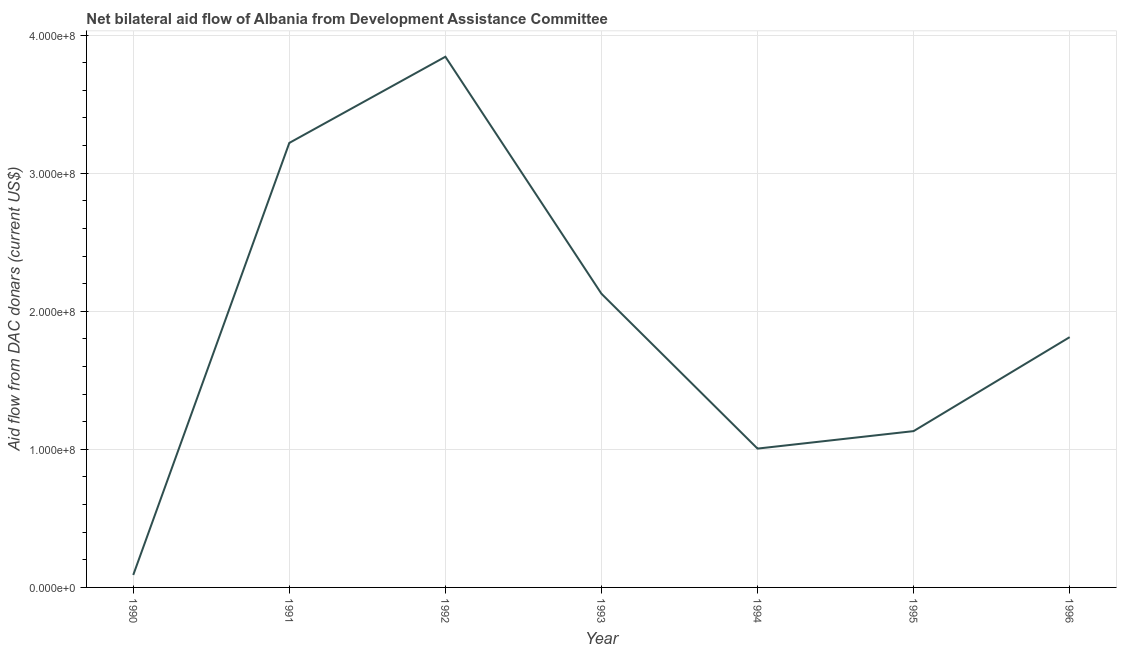What is the net bilateral aid flows from dac donors in 1990?
Ensure brevity in your answer.  9.02e+06. Across all years, what is the maximum net bilateral aid flows from dac donors?
Your response must be concise. 3.84e+08. Across all years, what is the minimum net bilateral aid flows from dac donors?
Make the answer very short. 9.02e+06. What is the sum of the net bilateral aid flows from dac donors?
Provide a short and direct response. 1.32e+09. What is the difference between the net bilateral aid flows from dac donors in 1990 and 1994?
Your answer should be very brief. -9.15e+07. What is the average net bilateral aid flows from dac donors per year?
Your answer should be compact. 1.89e+08. What is the median net bilateral aid flows from dac donors?
Keep it short and to the point. 1.81e+08. In how many years, is the net bilateral aid flows from dac donors greater than 260000000 US$?
Give a very brief answer. 2. What is the ratio of the net bilateral aid flows from dac donors in 1992 to that in 1995?
Provide a short and direct response. 3.4. Is the net bilateral aid flows from dac donors in 1991 less than that in 1993?
Give a very brief answer. No. What is the difference between the highest and the second highest net bilateral aid flows from dac donors?
Provide a succinct answer. 6.24e+07. What is the difference between the highest and the lowest net bilateral aid flows from dac donors?
Your answer should be compact. 3.75e+08. Does the graph contain any zero values?
Your answer should be compact. No. What is the title of the graph?
Provide a short and direct response. Net bilateral aid flow of Albania from Development Assistance Committee. What is the label or title of the Y-axis?
Your answer should be compact. Aid flow from DAC donars (current US$). What is the Aid flow from DAC donars (current US$) in 1990?
Give a very brief answer. 9.02e+06. What is the Aid flow from DAC donars (current US$) in 1991?
Ensure brevity in your answer.  3.22e+08. What is the Aid flow from DAC donars (current US$) of 1992?
Provide a short and direct response. 3.84e+08. What is the Aid flow from DAC donars (current US$) in 1993?
Offer a very short reply. 2.13e+08. What is the Aid flow from DAC donars (current US$) of 1994?
Your response must be concise. 1.01e+08. What is the Aid flow from DAC donars (current US$) of 1995?
Keep it short and to the point. 1.13e+08. What is the Aid flow from DAC donars (current US$) in 1996?
Ensure brevity in your answer.  1.81e+08. What is the difference between the Aid flow from DAC donars (current US$) in 1990 and 1991?
Provide a succinct answer. -3.13e+08. What is the difference between the Aid flow from DAC donars (current US$) in 1990 and 1992?
Your answer should be compact. -3.75e+08. What is the difference between the Aid flow from DAC donars (current US$) in 1990 and 1993?
Provide a succinct answer. -2.04e+08. What is the difference between the Aid flow from DAC donars (current US$) in 1990 and 1994?
Your answer should be compact. -9.15e+07. What is the difference between the Aid flow from DAC donars (current US$) in 1990 and 1995?
Your response must be concise. -1.04e+08. What is the difference between the Aid flow from DAC donars (current US$) in 1990 and 1996?
Provide a short and direct response. -1.72e+08. What is the difference between the Aid flow from DAC donars (current US$) in 1991 and 1992?
Make the answer very short. -6.24e+07. What is the difference between the Aid flow from DAC donars (current US$) in 1991 and 1993?
Give a very brief answer. 1.09e+08. What is the difference between the Aid flow from DAC donars (current US$) in 1991 and 1994?
Your response must be concise. 2.21e+08. What is the difference between the Aid flow from DAC donars (current US$) in 1991 and 1995?
Offer a very short reply. 2.09e+08. What is the difference between the Aid flow from DAC donars (current US$) in 1991 and 1996?
Make the answer very short. 1.41e+08. What is the difference between the Aid flow from DAC donars (current US$) in 1992 and 1993?
Provide a succinct answer. 1.72e+08. What is the difference between the Aid flow from DAC donars (current US$) in 1992 and 1994?
Provide a succinct answer. 2.84e+08. What is the difference between the Aid flow from DAC donars (current US$) in 1992 and 1995?
Provide a succinct answer. 2.71e+08. What is the difference between the Aid flow from DAC donars (current US$) in 1992 and 1996?
Give a very brief answer. 2.03e+08. What is the difference between the Aid flow from DAC donars (current US$) in 1993 and 1994?
Provide a short and direct response. 1.12e+08. What is the difference between the Aid flow from DAC donars (current US$) in 1993 and 1995?
Offer a terse response. 9.95e+07. What is the difference between the Aid flow from DAC donars (current US$) in 1993 and 1996?
Provide a short and direct response. 3.14e+07. What is the difference between the Aid flow from DAC donars (current US$) in 1994 and 1995?
Your response must be concise. -1.27e+07. What is the difference between the Aid flow from DAC donars (current US$) in 1994 and 1996?
Offer a very short reply. -8.07e+07. What is the difference between the Aid flow from DAC donars (current US$) in 1995 and 1996?
Give a very brief answer. -6.80e+07. What is the ratio of the Aid flow from DAC donars (current US$) in 1990 to that in 1991?
Offer a terse response. 0.03. What is the ratio of the Aid flow from DAC donars (current US$) in 1990 to that in 1992?
Your answer should be compact. 0.02. What is the ratio of the Aid flow from DAC donars (current US$) in 1990 to that in 1993?
Ensure brevity in your answer.  0.04. What is the ratio of the Aid flow from DAC donars (current US$) in 1990 to that in 1994?
Offer a terse response. 0.09. What is the ratio of the Aid flow from DAC donars (current US$) in 1990 to that in 1996?
Keep it short and to the point. 0.05. What is the ratio of the Aid flow from DAC donars (current US$) in 1991 to that in 1992?
Your response must be concise. 0.84. What is the ratio of the Aid flow from DAC donars (current US$) in 1991 to that in 1993?
Provide a succinct answer. 1.51. What is the ratio of the Aid flow from DAC donars (current US$) in 1991 to that in 1994?
Your answer should be compact. 3.2. What is the ratio of the Aid flow from DAC donars (current US$) in 1991 to that in 1995?
Provide a succinct answer. 2.84. What is the ratio of the Aid flow from DAC donars (current US$) in 1991 to that in 1996?
Ensure brevity in your answer.  1.78. What is the ratio of the Aid flow from DAC donars (current US$) in 1992 to that in 1993?
Provide a succinct answer. 1.81. What is the ratio of the Aid flow from DAC donars (current US$) in 1992 to that in 1994?
Offer a terse response. 3.82. What is the ratio of the Aid flow from DAC donars (current US$) in 1992 to that in 1995?
Provide a short and direct response. 3.4. What is the ratio of the Aid flow from DAC donars (current US$) in 1992 to that in 1996?
Your answer should be very brief. 2.12. What is the ratio of the Aid flow from DAC donars (current US$) in 1993 to that in 1994?
Provide a short and direct response. 2.12. What is the ratio of the Aid flow from DAC donars (current US$) in 1993 to that in 1995?
Ensure brevity in your answer.  1.88. What is the ratio of the Aid flow from DAC donars (current US$) in 1993 to that in 1996?
Ensure brevity in your answer.  1.17. What is the ratio of the Aid flow from DAC donars (current US$) in 1994 to that in 1995?
Ensure brevity in your answer.  0.89. What is the ratio of the Aid flow from DAC donars (current US$) in 1994 to that in 1996?
Provide a succinct answer. 0.56. 